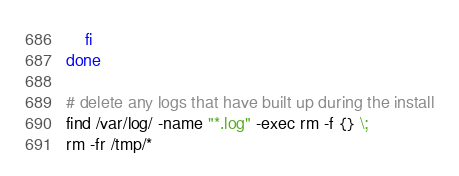<code> <loc_0><loc_0><loc_500><loc_500><_Bash_>    fi
done

# delete any logs that have built up during the install
find /var/log/ -name "*.log" -exec rm -f {} \;
rm -fr /tmp/*
</code> 